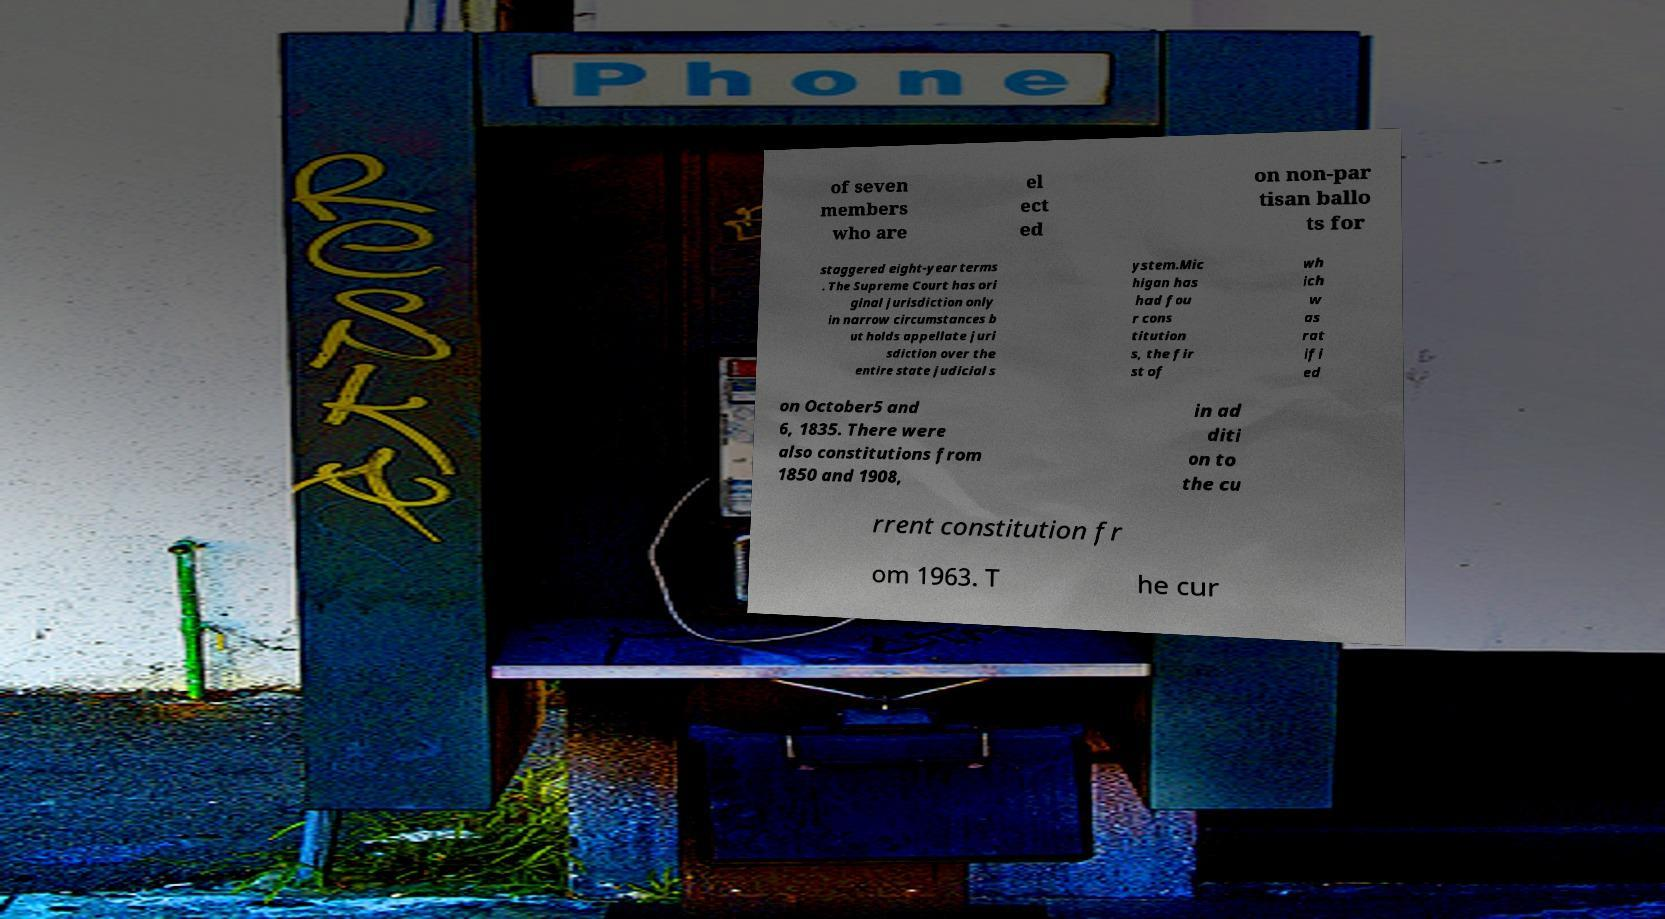I need the written content from this picture converted into text. Can you do that? of seven members who are el ect ed on non-par tisan ballo ts for staggered eight-year terms . The Supreme Court has ori ginal jurisdiction only in narrow circumstances b ut holds appellate juri sdiction over the entire state judicial s ystem.Mic higan has had fou r cons titution s, the fir st of wh ich w as rat ifi ed on October5 and 6, 1835. There were also constitutions from 1850 and 1908, in ad diti on to the cu rrent constitution fr om 1963. T he cur 